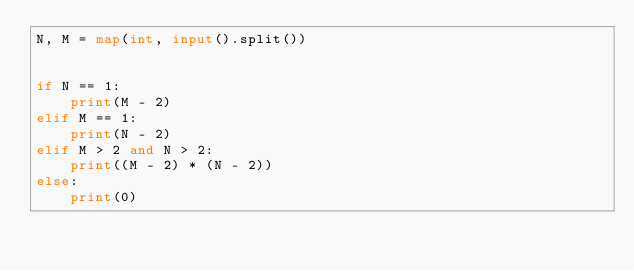<code> <loc_0><loc_0><loc_500><loc_500><_Python_>N, M = map(int, input().split())


if N == 1:
    print(M - 2)
elif M == 1:
    print(N - 2)
elif M > 2 and N > 2:
    print((M - 2) * (N - 2))
else:
    print(0)
</code> 